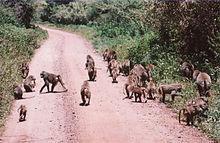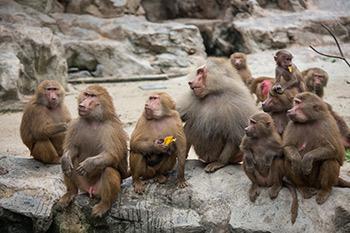The first image is the image on the left, the second image is the image on the right. For the images displayed, is the sentence "There are no more than four monkeys in the image on the left." factually correct? Answer yes or no. No. 